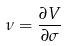<formula> <loc_0><loc_0><loc_500><loc_500>\nu = \frac { \partial V } { \partial \sigma }</formula> 